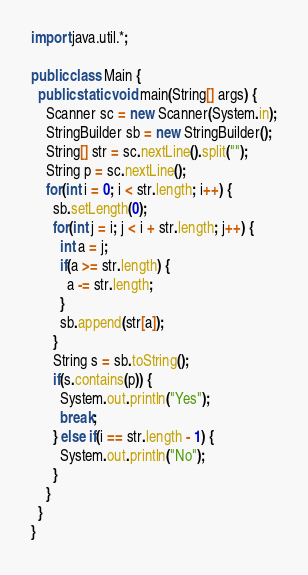<code> <loc_0><loc_0><loc_500><loc_500><_Java_>import java.util.*;

public class Main {
  public static void main(String[] args) {
    Scanner sc = new Scanner(System.in);
    StringBuilder sb = new StringBuilder();
    String[] str = sc.nextLine().split("");
    String p = sc.nextLine();
    for(int i = 0; i < str.length; i++) {
      sb.setLength(0);
      for(int j = i; j < i + str.length; j++) {
        int a = j;
        if(a >= str.length) {
          a -= str.length;
        }
        sb.append(str[a]);
      }
      String s = sb.toString();
      if(s.contains(p)) {
        System.out.println("Yes");
        break;
      } else if(i == str.length - 1) {
        System.out.println("No");
      }
    }
  }
}

</code> 